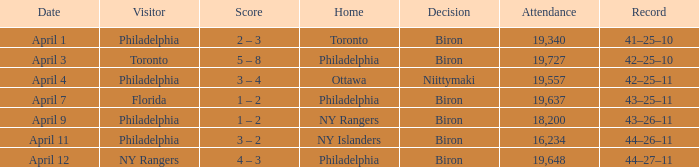Who were the visitors when the home team were the ny rangers? Philadelphia. 